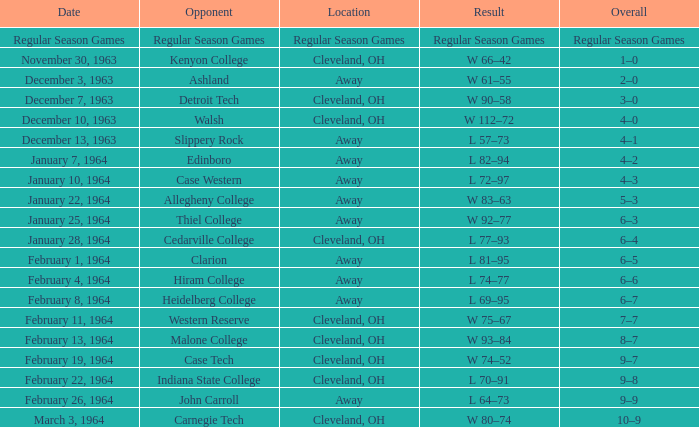For the date february 4, 1964, what is the overall? 6–6. 